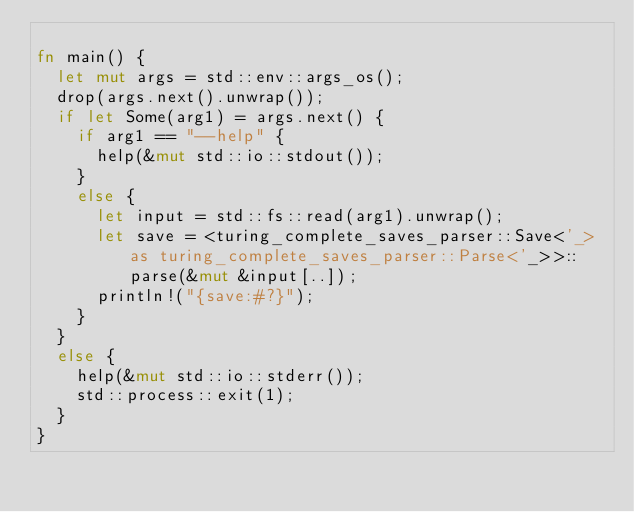<code> <loc_0><loc_0><loc_500><loc_500><_Rust_>
fn main() {
	let mut args = std::env::args_os();
	drop(args.next().unwrap());
	if let Some(arg1) = args.next() {
		if arg1 == "--help" {
			help(&mut std::io::stdout());
		}
		else {
			let input = std::fs::read(arg1).unwrap();
			let save = <turing_complete_saves_parser::Save<'_> as turing_complete_saves_parser::Parse<'_>>::parse(&mut &input[..]);
			println!("{save:#?}");
		}
	}
	else {
		help(&mut std::io::stderr());
		std::process::exit(1);
	}
}
</code> 